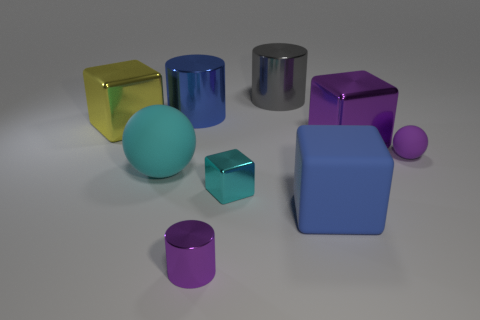The blue cube has what size?
Give a very brief answer. Large. Are there more big metallic things that are on the right side of the small metallic cube than blue cubes?
Provide a short and direct response. Yes. Is the number of purple matte things that are on the right side of the large gray object the same as the number of shiny blocks that are in front of the tiny cyan thing?
Offer a terse response. No. There is a metal cube that is in front of the yellow metal cube and behind the cyan metal cube; what color is it?
Provide a short and direct response. Purple. Is the number of metal cubes that are in front of the tiny purple matte object greater than the number of big blue rubber blocks on the left side of the blue metal cylinder?
Ensure brevity in your answer.  Yes. There is a cylinder that is right of the purple cylinder; is its size the same as the big cyan thing?
Your response must be concise. Yes. There is a rubber object to the left of the blue object behind the big rubber ball; how many matte balls are right of it?
Provide a succinct answer. 1. There is a metal object that is in front of the big cyan matte object and behind the small purple metal cylinder; what is its size?
Keep it short and to the point. Small. What number of other things are the same shape as the big purple object?
Your response must be concise. 3. There is a big yellow metallic object; what number of metal blocks are behind it?
Provide a succinct answer. 0. 